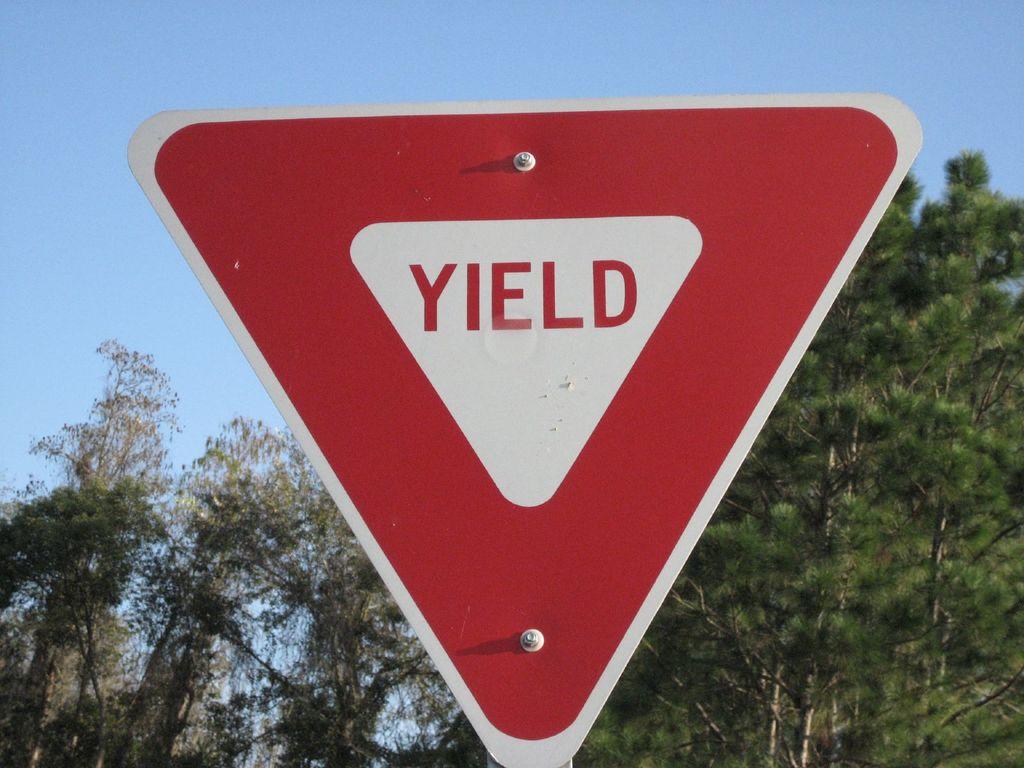What does the sign say?
Provide a short and direct response. Yield. 